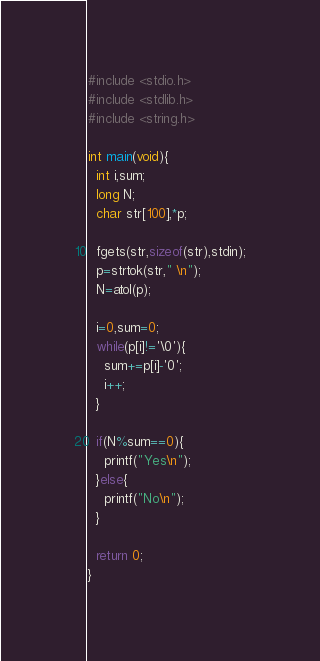Convert code to text. <code><loc_0><loc_0><loc_500><loc_500><_C_>#include <stdio.h>
#include <stdlib.h>
#include <string.h>

int main(void){
  int i,sum;
  long N;
  char str[100],*p;
  
  fgets(str,sizeof(str),stdin);
  p=strtok(str," \n");
  N=atol(p);
  
  i=0,sum=0;
  while(p[i]!='\0'){
    sum+=p[i]-'0';
    i++;
  }
  
  if(N%sum==0){
    printf("Yes\n");
  }else{
    printf("No\n");
  }
  
  return 0;
}</code> 